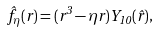Convert formula to latex. <formula><loc_0><loc_0><loc_500><loc_500>\hat { f } _ { \eta } ( { r } ) = ( r ^ { 3 } - \eta r ) Y _ { 1 0 } ( \hat { r } ) ,</formula> 